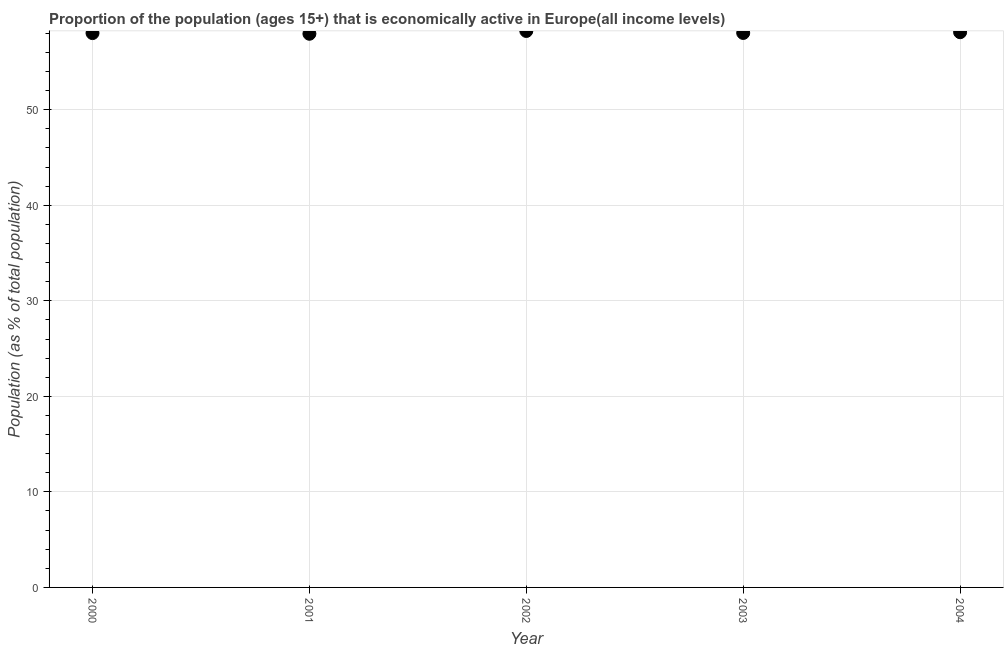What is the percentage of economically active population in 2002?
Keep it short and to the point. 58.25. Across all years, what is the maximum percentage of economically active population?
Your answer should be compact. 58.25. Across all years, what is the minimum percentage of economically active population?
Provide a succinct answer. 57.96. What is the sum of the percentage of economically active population?
Provide a succinct answer. 290.39. What is the difference between the percentage of economically active population in 2000 and 2001?
Give a very brief answer. 0.07. What is the average percentage of economically active population per year?
Provide a succinct answer. 58.08. What is the median percentage of economically active population?
Your response must be concise. 58.04. What is the ratio of the percentage of economically active population in 2002 to that in 2003?
Offer a very short reply. 1. Is the percentage of economically active population in 2002 less than that in 2003?
Give a very brief answer. No. What is the difference between the highest and the second highest percentage of economically active population?
Offer a very short reply. 0.13. What is the difference between the highest and the lowest percentage of economically active population?
Offer a very short reply. 0.29. In how many years, is the percentage of economically active population greater than the average percentage of economically active population taken over all years?
Your answer should be compact. 2. Does the percentage of economically active population monotonically increase over the years?
Ensure brevity in your answer.  No. How many years are there in the graph?
Ensure brevity in your answer.  5. Does the graph contain any zero values?
Provide a succinct answer. No. Does the graph contain grids?
Give a very brief answer. Yes. What is the title of the graph?
Keep it short and to the point. Proportion of the population (ages 15+) that is economically active in Europe(all income levels). What is the label or title of the X-axis?
Provide a succinct answer. Year. What is the label or title of the Y-axis?
Offer a very short reply. Population (as % of total population). What is the Population (as % of total population) in 2000?
Ensure brevity in your answer.  58.03. What is the Population (as % of total population) in 2001?
Offer a terse response. 57.96. What is the Population (as % of total population) in 2002?
Offer a very short reply. 58.25. What is the Population (as % of total population) in 2003?
Ensure brevity in your answer.  58.04. What is the Population (as % of total population) in 2004?
Offer a terse response. 58.12. What is the difference between the Population (as % of total population) in 2000 and 2001?
Give a very brief answer. 0.07. What is the difference between the Population (as % of total population) in 2000 and 2002?
Your answer should be very brief. -0.22. What is the difference between the Population (as % of total population) in 2000 and 2003?
Make the answer very short. -0.01. What is the difference between the Population (as % of total population) in 2000 and 2004?
Provide a succinct answer. -0.09. What is the difference between the Population (as % of total population) in 2001 and 2002?
Provide a short and direct response. -0.29. What is the difference between the Population (as % of total population) in 2001 and 2003?
Offer a terse response. -0.08. What is the difference between the Population (as % of total population) in 2001 and 2004?
Provide a short and direct response. -0.16. What is the difference between the Population (as % of total population) in 2002 and 2003?
Give a very brief answer. 0.21. What is the difference between the Population (as % of total population) in 2002 and 2004?
Keep it short and to the point. 0.13. What is the difference between the Population (as % of total population) in 2003 and 2004?
Give a very brief answer. -0.08. What is the ratio of the Population (as % of total population) in 2000 to that in 2001?
Your answer should be compact. 1. What is the ratio of the Population (as % of total population) in 2000 to that in 2002?
Give a very brief answer. 1. What is the ratio of the Population (as % of total population) in 2000 to that in 2003?
Offer a very short reply. 1. What is the ratio of the Population (as % of total population) in 2000 to that in 2004?
Make the answer very short. 1. 